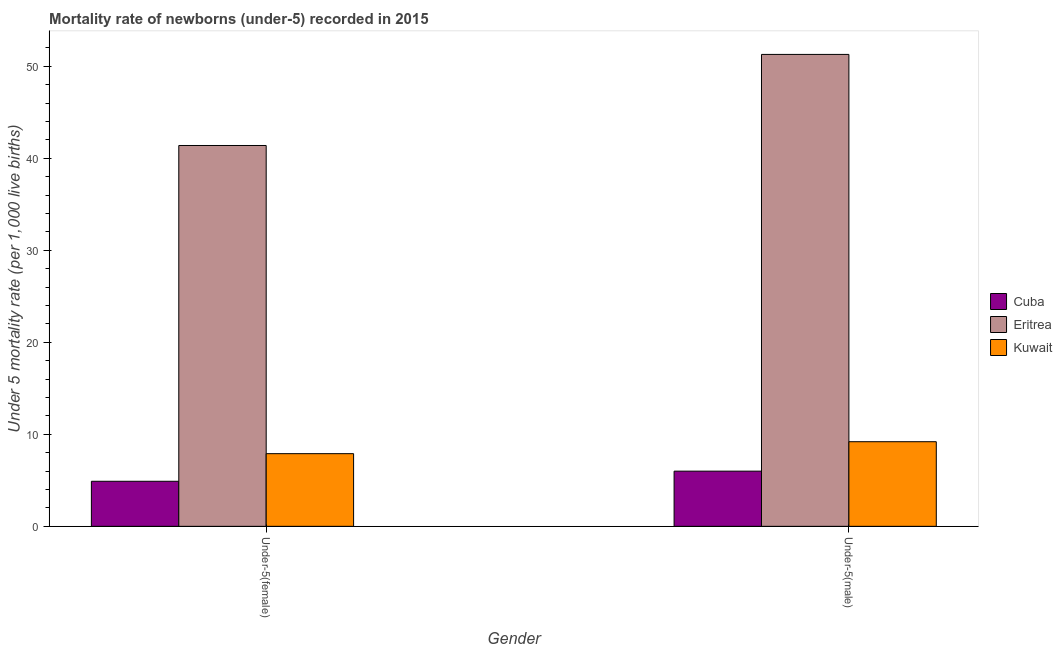How many groups of bars are there?
Provide a succinct answer. 2. Are the number of bars per tick equal to the number of legend labels?
Your answer should be compact. Yes. Are the number of bars on each tick of the X-axis equal?
Provide a succinct answer. Yes. How many bars are there on the 1st tick from the right?
Offer a very short reply. 3. What is the label of the 1st group of bars from the left?
Provide a short and direct response. Under-5(female). What is the under-5 female mortality rate in Eritrea?
Your answer should be compact. 41.4. Across all countries, what is the maximum under-5 female mortality rate?
Offer a terse response. 41.4. Across all countries, what is the minimum under-5 male mortality rate?
Make the answer very short. 6. In which country was the under-5 male mortality rate maximum?
Keep it short and to the point. Eritrea. In which country was the under-5 male mortality rate minimum?
Make the answer very short. Cuba. What is the total under-5 female mortality rate in the graph?
Provide a short and direct response. 54.2. What is the difference between the under-5 male mortality rate in Eritrea and that in Cuba?
Your answer should be compact. 45.3. What is the difference between the under-5 female mortality rate in Eritrea and the under-5 male mortality rate in Cuba?
Offer a very short reply. 35.4. What is the average under-5 male mortality rate per country?
Make the answer very short. 22.17. What is the difference between the under-5 male mortality rate and under-5 female mortality rate in Eritrea?
Offer a terse response. 9.9. What is the ratio of the under-5 female mortality rate in Cuba to that in Eritrea?
Provide a succinct answer. 0.12. Is the under-5 male mortality rate in Eritrea less than that in Kuwait?
Give a very brief answer. No. What does the 2nd bar from the left in Under-5(female) represents?
Your answer should be compact. Eritrea. What does the 1st bar from the right in Under-5(male) represents?
Offer a very short reply. Kuwait. How many bars are there?
Offer a very short reply. 6. How many countries are there in the graph?
Give a very brief answer. 3. Are the values on the major ticks of Y-axis written in scientific E-notation?
Your response must be concise. No. Does the graph contain any zero values?
Make the answer very short. No. Does the graph contain grids?
Offer a very short reply. No. Where does the legend appear in the graph?
Offer a very short reply. Center right. How many legend labels are there?
Keep it short and to the point. 3. How are the legend labels stacked?
Keep it short and to the point. Vertical. What is the title of the graph?
Offer a very short reply. Mortality rate of newborns (under-5) recorded in 2015. Does "High income: nonOECD" appear as one of the legend labels in the graph?
Ensure brevity in your answer.  No. What is the label or title of the Y-axis?
Your response must be concise. Under 5 mortality rate (per 1,0 live births). What is the Under 5 mortality rate (per 1,000 live births) of Cuba in Under-5(female)?
Your response must be concise. 4.9. What is the Under 5 mortality rate (per 1,000 live births) in Eritrea in Under-5(female)?
Provide a short and direct response. 41.4. What is the Under 5 mortality rate (per 1,000 live births) of Kuwait in Under-5(female)?
Make the answer very short. 7.9. What is the Under 5 mortality rate (per 1,000 live births) in Eritrea in Under-5(male)?
Give a very brief answer. 51.3. Across all Gender, what is the maximum Under 5 mortality rate (per 1,000 live births) in Cuba?
Provide a succinct answer. 6. Across all Gender, what is the maximum Under 5 mortality rate (per 1,000 live births) in Eritrea?
Make the answer very short. 51.3. Across all Gender, what is the maximum Under 5 mortality rate (per 1,000 live births) in Kuwait?
Provide a short and direct response. 9.2. Across all Gender, what is the minimum Under 5 mortality rate (per 1,000 live births) in Eritrea?
Ensure brevity in your answer.  41.4. What is the total Under 5 mortality rate (per 1,000 live births) in Cuba in the graph?
Ensure brevity in your answer.  10.9. What is the total Under 5 mortality rate (per 1,000 live births) in Eritrea in the graph?
Provide a succinct answer. 92.7. What is the total Under 5 mortality rate (per 1,000 live births) in Kuwait in the graph?
Your answer should be compact. 17.1. What is the difference between the Under 5 mortality rate (per 1,000 live births) in Cuba in Under-5(female) and the Under 5 mortality rate (per 1,000 live births) in Eritrea in Under-5(male)?
Ensure brevity in your answer.  -46.4. What is the difference between the Under 5 mortality rate (per 1,000 live births) in Eritrea in Under-5(female) and the Under 5 mortality rate (per 1,000 live births) in Kuwait in Under-5(male)?
Provide a short and direct response. 32.2. What is the average Under 5 mortality rate (per 1,000 live births) of Cuba per Gender?
Offer a very short reply. 5.45. What is the average Under 5 mortality rate (per 1,000 live births) of Eritrea per Gender?
Provide a succinct answer. 46.35. What is the average Under 5 mortality rate (per 1,000 live births) in Kuwait per Gender?
Provide a succinct answer. 8.55. What is the difference between the Under 5 mortality rate (per 1,000 live births) in Cuba and Under 5 mortality rate (per 1,000 live births) in Eritrea in Under-5(female)?
Keep it short and to the point. -36.5. What is the difference between the Under 5 mortality rate (per 1,000 live births) of Cuba and Under 5 mortality rate (per 1,000 live births) of Kuwait in Under-5(female)?
Your response must be concise. -3. What is the difference between the Under 5 mortality rate (per 1,000 live births) in Eritrea and Under 5 mortality rate (per 1,000 live births) in Kuwait in Under-5(female)?
Make the answer very short. 33.5. What is the difference between the Under 5 mortality rate (per 1,000 live births) of Cuba and Under 5 mortality rate (per 1,000 live births) of Eritrea in Under-5(male)?
Provide a short and direct response. -45.3. What is the difference between the Under 5 mortality rate (per 1,000 live births) in Cuba and Under 5 mortality rate (per 1,000 live births) in Kuwait in Under-5(male)?
Ensure brevity in your answer.  -3.2. What is the difference between the Under 5 mortality rate (per 1,000 live births) of Eritrea and Under 5 mortality rate (per 1,000 live births) of Kuwait in Under-5(male)?
Your response must be concise. 42.1. What is the ratio of the Under 5 mortality rate (per 1,000 live births) in Cuba in Under-5(female) to that in Under-5(male)?
Offer a terse response. 0.82. What is the ratio of the Under 5 mortality rate (per 1,000 live births) of Eritrea in Under-5(female) to that in Under-5(male)?
Keep it short and to the point. 0.81. What is the ratio of the Under 5 mortality rate (per 1,000 live births) in Kuwait in Under-5(female) to that in Under-5(male)?
Keep it short and to the point. 0.86. What is the difference between the highest and the second highest Under 5 mortality rate (per 1,000 live births) in Cuba?
Give a very brief answer. 1.1. What is the difference between the highest and the second highest Under 5 mortality rate (per 1,000 live births) in Eritrea?
Make the answer very short. 9.9. What is the difference between the highest and the second highest Under 5 mortality rate (per 1,000 live births) of Kuwait?
Offer a terse response. 1.3. What is the difference between the highest and the lowest Under 5 mortality rate (per 1,000 live births) of Cuba?
Your answer should be compact. 1.1. What is the difference between the highest and the lowest Under 5 mortality rate (per 1,000 live births) in Eritrea?
Provide a short and direct response. 9.9. What is the difference between the highest and the lowest Under 5 mortality rate (per 1,000 live births) in Kuwait?
Provide a succinct answer. 1.3. 